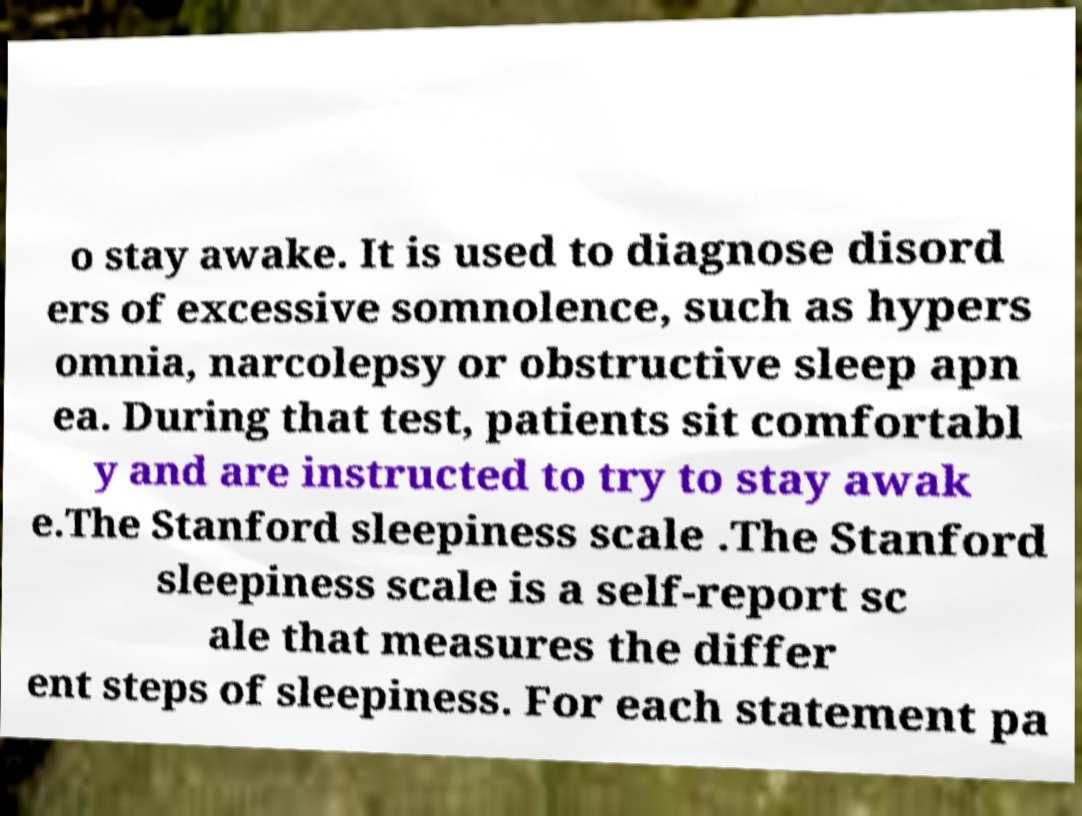Can you accurately transcribe the text from the provided image for me? o stay awake. It is used to diagnose disord ers of excessive somnolence, such as hypers omnia, narcolepsy or obstructive sleep apn ea. During that test, patients sit comfortabl y and are instructed to try to stay awak e.The Stanford sleepiness scale .The Stanford sleepiness scale is a self-report sc ale that measures the differ ent steps of sleepiness. For each statement pa 